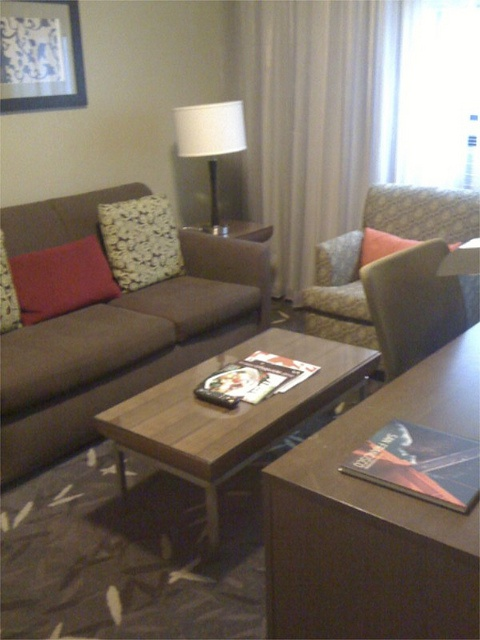Describe the objects in this image and their specific colors. I can see couch in gray, maroon, and black tones, chair in gray and darkgray tones, chair in gray and black tones, book in gray and salmon tones, and book in gray, ivory, darkgray, and tan tones in this image. 